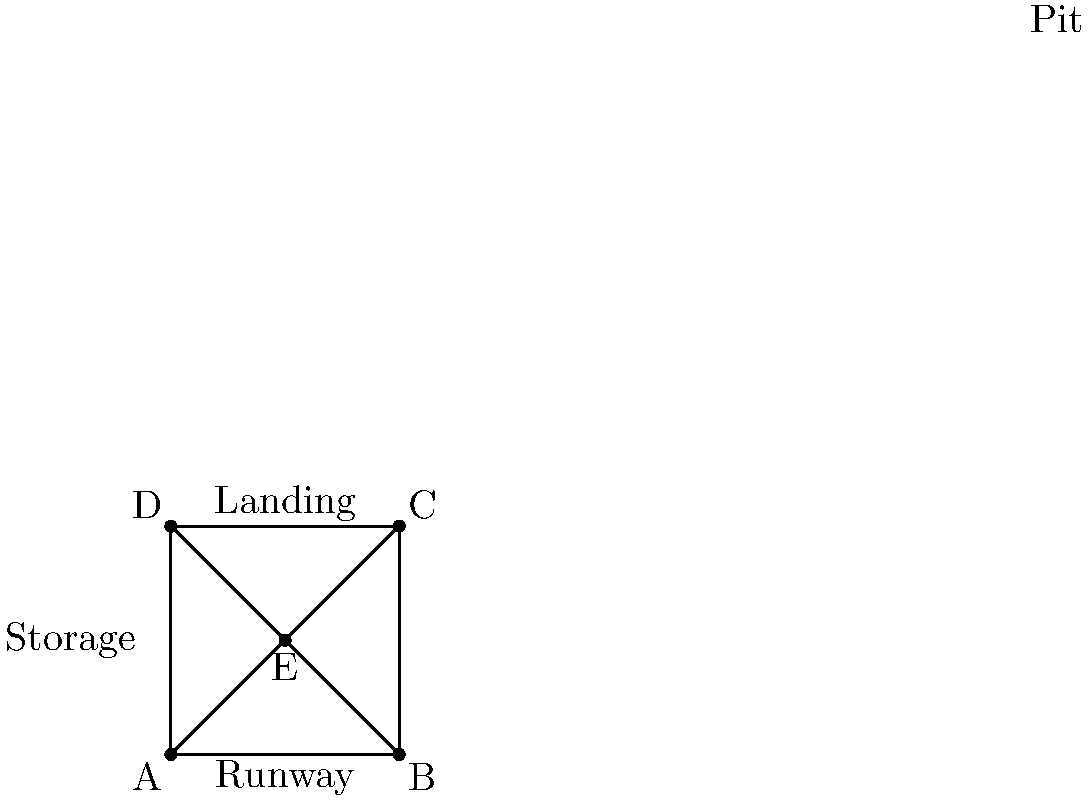Consider the layout of a pole vault training facility shown above. The facility has a square shape with four distinct areas: Runway, Landing Pit, Storage, and Pit. The layout exhibits symmetries that form a dihedral group. How many elements are in this dihedral group? To determine the number of elements in the dihedral group for this layout, we need to identify the symmetries:

1. Rotational symmetries:
   - Identity (0° rotation)
   - 90° clockwise rotation
   - 180° rotation
   - 270° clockwise rotation (or 90° counterclockwise)

2. Reflection symmetries:
   - Reflection across the vertical line (A-C)
   - Reflection across the horizontal line (B-D)
   - Reflection across the diagonal line (A-C)
   - Reflection across the other diagonal line (B-D)

The total number of symmetries is the sum of rotational and reflection symmetries:
$$ 4 \text{ rotations} + 4 \text{ reflections} = 8 \text{ symmetries} $$

In group theory, the dihedral group $D_n$ represents the symmetries of a regular n-gon. In this case, we have a square, so this is the dihedral group $D_4$.

The order of the dihedral group $D_n$ is given by the formula:
$$ |D_n| = 2n $$

For our square layout, $n = 4$, so:
$$ |D_4| = 2 \cdot 4 = 8 $$

This confirms our count of 8 symmetries.
Answer: 8 